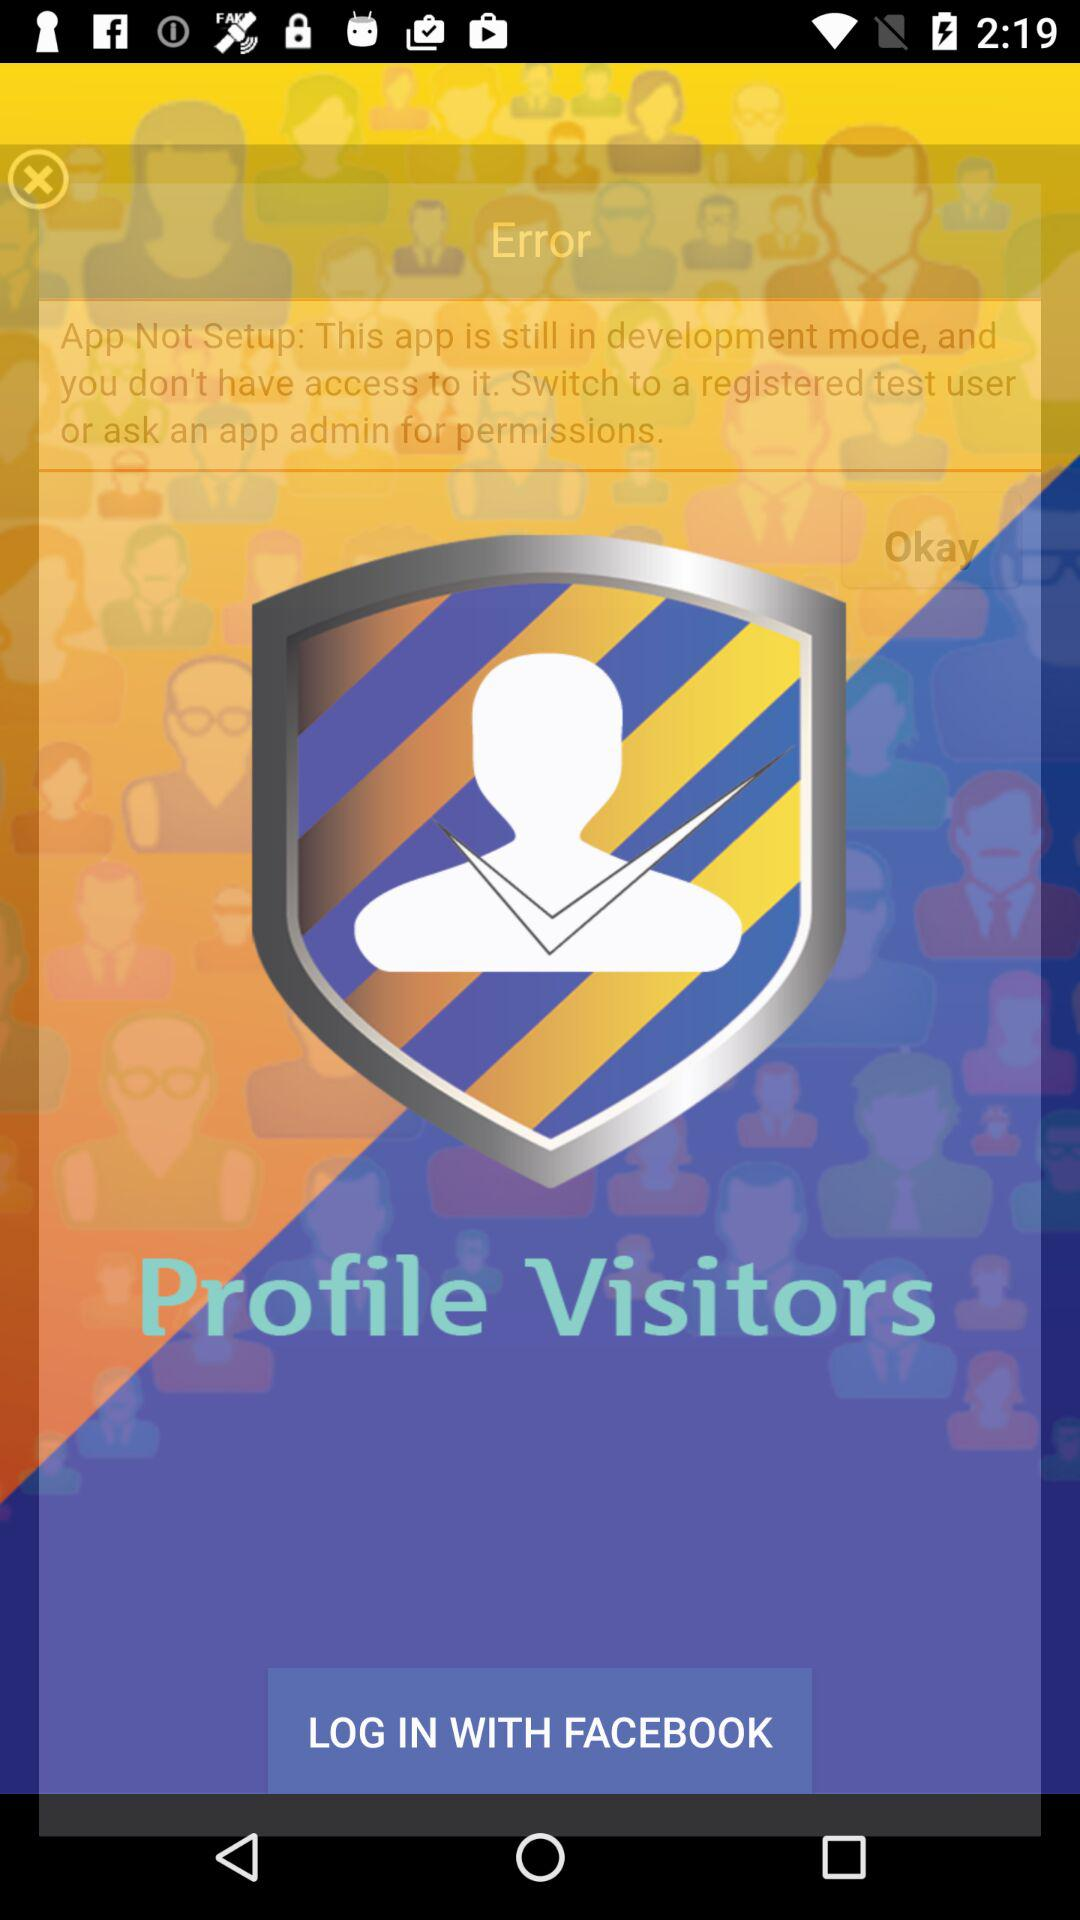Through what application can we log in? We can log in through "FACEBOOK". 